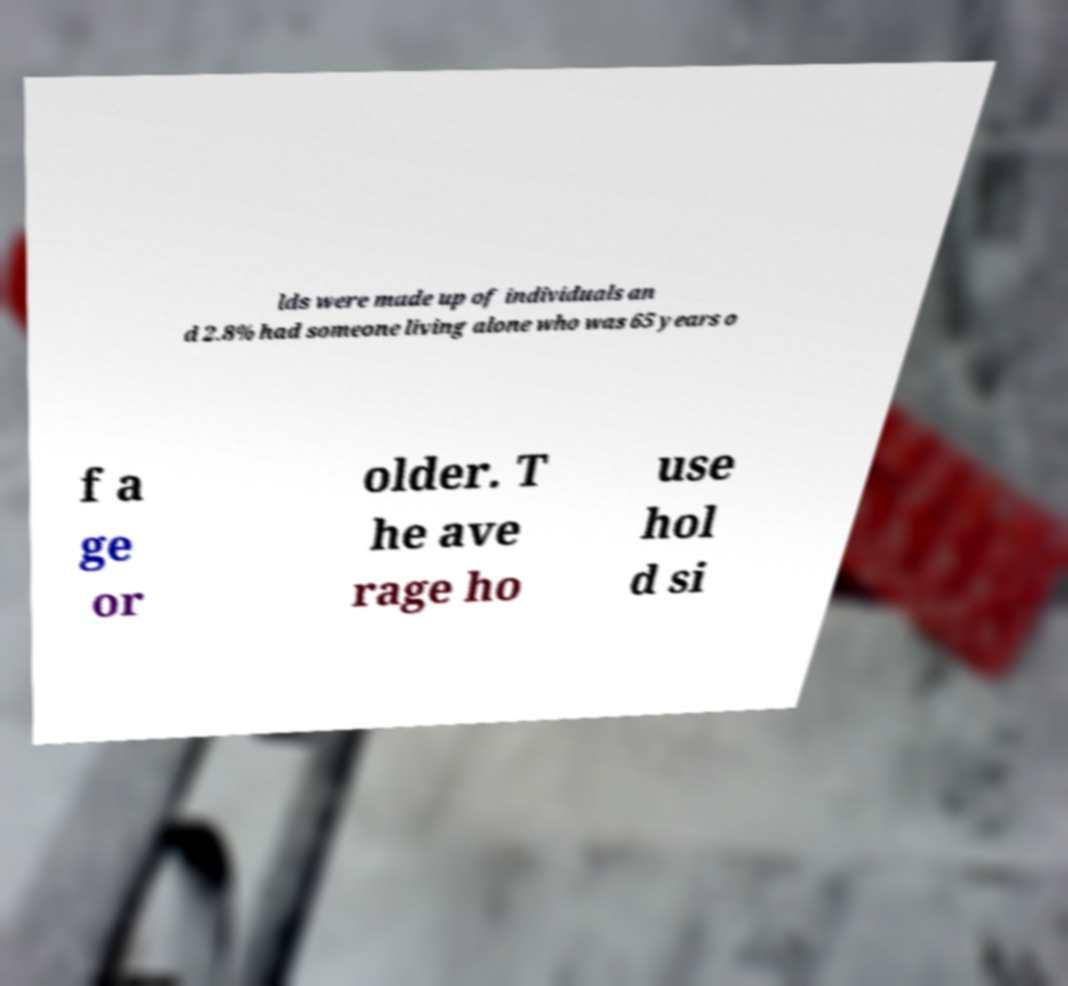For documentation purposes, I need the text within this image transcribed. Could you provide that? lds were made up of individuals an d 2.8% had someone living alone who was 65 years o f a ge or older. T he ave rage ho use hol d si 